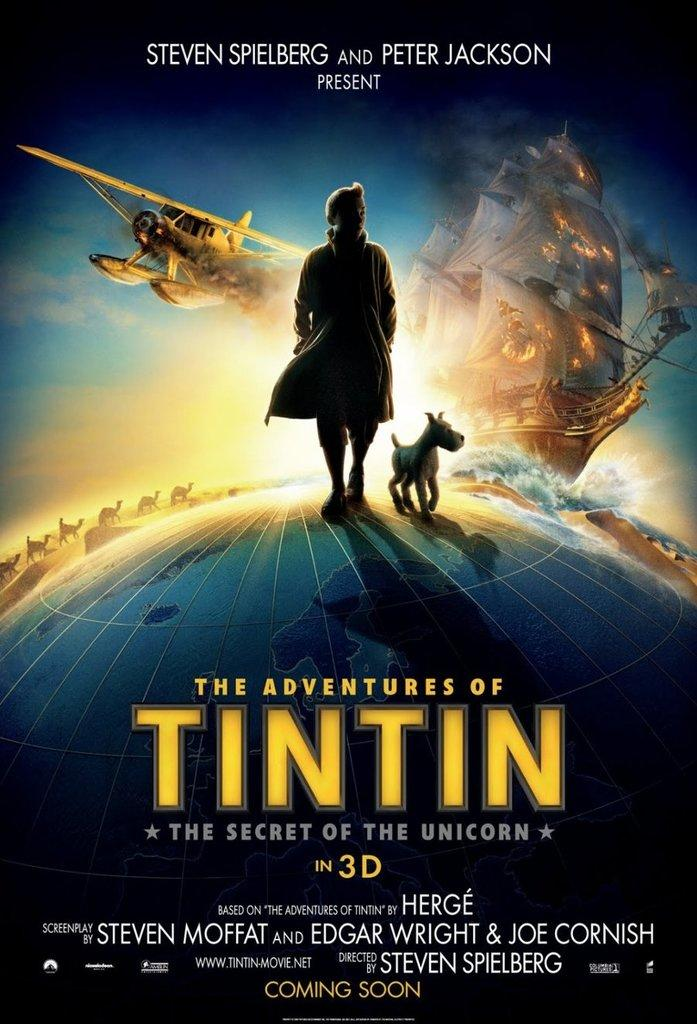What is the main subject of the image? The image contains a poster. What characters or objects are depicted on the poster? The poster has a person, a dog, a jet, and a ship in it. Is there any text present in the image? Yes, there is text at the bottom of the image. Can you tell me how many monkeys are holding a wrench in the image? There are no monkeys or wrenches present in the image. What type of glue is being used to attach the poster to the wall in the image? The image does not show the poster being attached to the wall, so it is not possible to determine what type of glue might be used. 